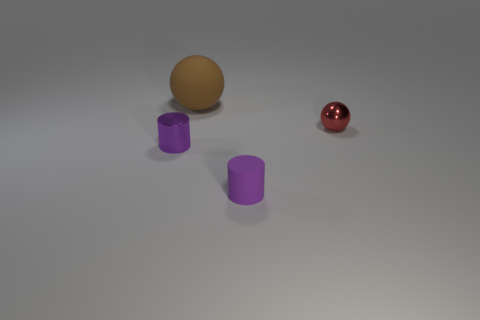Is the size of the cylinder behind the purple matte cylinder the same as the big matte sphere?
Offer a very short reply. No. How many other things are the same shape as the large thing?
Provide a succinct answer. 1. Do the cylinder on the left side of the tiny rubber cylinder and the tiny matte thing have the same color?
Make the answer very short. Yes. Is there another rubber sphere that has the same color as the big ball?
Offer a very short reply. No. How many rubber objects are in front of the small purple metal thing?
Ensure brevity in your answer.  1. How many other things are there of the same size as the red metal thing?
Give a very brief answer. 2. Is the material of the tiny object that is to the left of the large brown object the same as the purple cylinder in front of the tiny purple shiny thing?
Your response must be concise. No. What is the color of the other metal object that is the same size as the purple shiny object?
Offer a terse response. Red. Is there any other thing of the same color as the small rubber cylinder?
Offer a terse response. Yes. What is the size of the sphere to the left of the matte thing on the right side of the big brown sphere that is behind the purple metallic cylinder?
Your response must be concise. Large. 